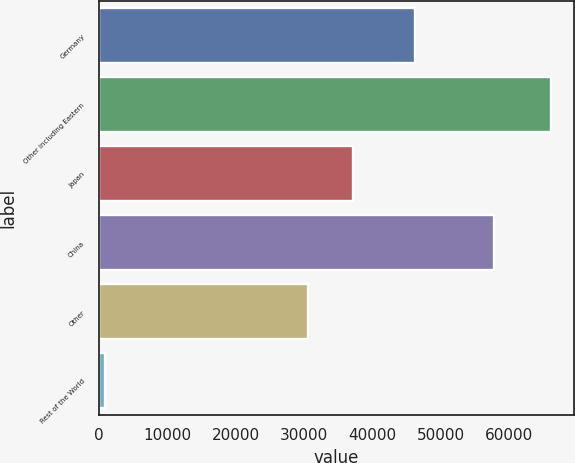Convert chart. <chart><loc_0><loc_0><loc_500><loc_500><bar_chart><fcel>Germany<fcel>Other including Eastern<fcel>Japan<fcel>China<fcel>Other<fcel>Rest of the World<nl><fcel>46282<fcel>66174<fcel>37147.4<fcel>57762<fcel>30614<fcel>840<nl></chart> 